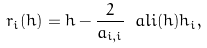Convert formula to latex. <formula><loc_0><loc_0><loc_500><loc_500>r _ { i } ( h ) = h - \frac { 2 } { a _ { i , i } } \ a l i ( h ) h _ { i } ,</formula> 